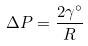Convert formula to latex. <formula><loc_0><loc_0><loc_500><loc_500>\Delta P = \frac { 2 \gamma ^ { \circ } } { R }</formula> 